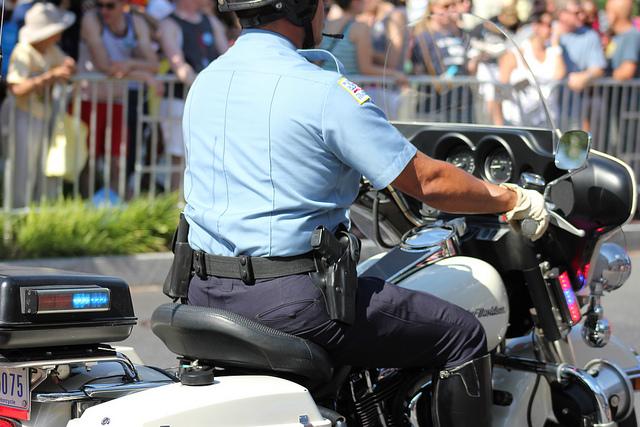What brand of motorcycle is he riding?
Write a very short answer. Harley. What is the emblem on the motorcycle?
Concise answer only. Harley davidson. What are the people standing behind?
Be succinct. Fence. 